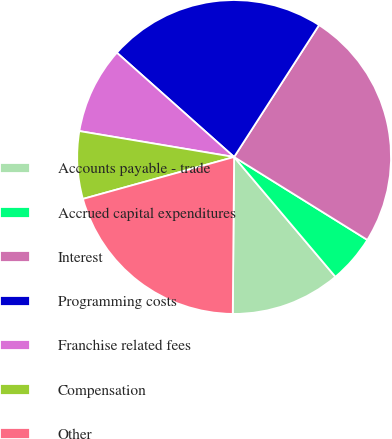Convert chart. <chart><loc_0><loc_0><loc_500><loc_500><pie_chart><fcel>Accounts payable - trade<fcel>Accrued capital expenditures<fcel>Interest<fcel>Programming costs<fcel>Franchise related fees<fcel>Compensation<fcel>Other<nl><fcel>11.31%<fcel>4.97%<fcel>24.76%<fcel>22.54%<fcel>8.93%<fcel>6.95%<fcel>20.56%<nl></chart> 